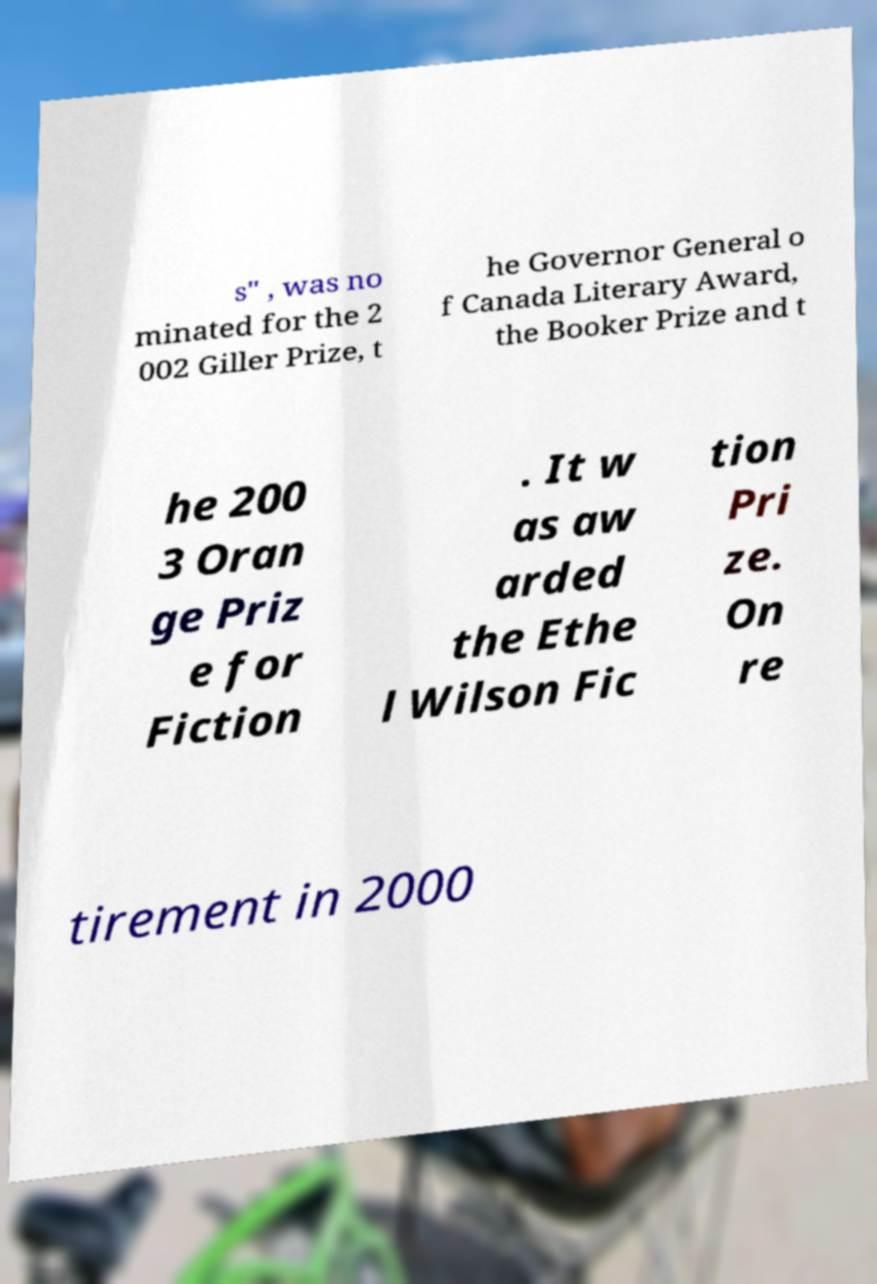I need the written content from this picture converted into text. Can you do that? s" , was no minated for the 2 002 Giller Prize, t he Governor General o f Canada Literary Award, the Booker Prize and t he 200 3 Oran ge Priz e for Fiction . It w as aw arded the Ethe l Wilson Fic tion Pri ze. On re tirement in 2000 